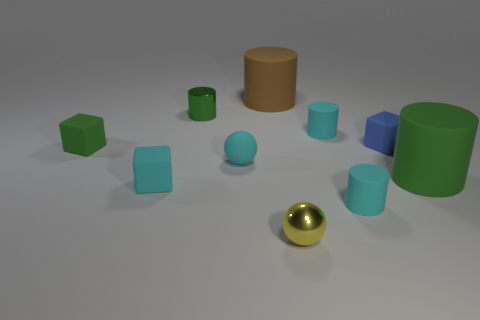What sort of materials do these objects appear to be made from? The objects display a variety of matte and slightly reflective surfaces, suggesting they may be made of different plastics or coated metals. This combination of materials contributes further to the image's diverse visual texture. 